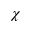Convert formula to latex. <formula><loc_0><loc_0><loc_500><loc_500>\chi</formula> 